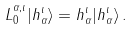Convert formula to latex. <formula><loc_0><loc_0><loc_500><loc_500>L _ { 0 } ^ { \alpha , \iota } | h _ { \alpha } ^ { \iota } \rangle = h _ { \alpha } ^ { \iota } | h _ { \alpha } ^ { \iota } \rangle \, .</formula> 